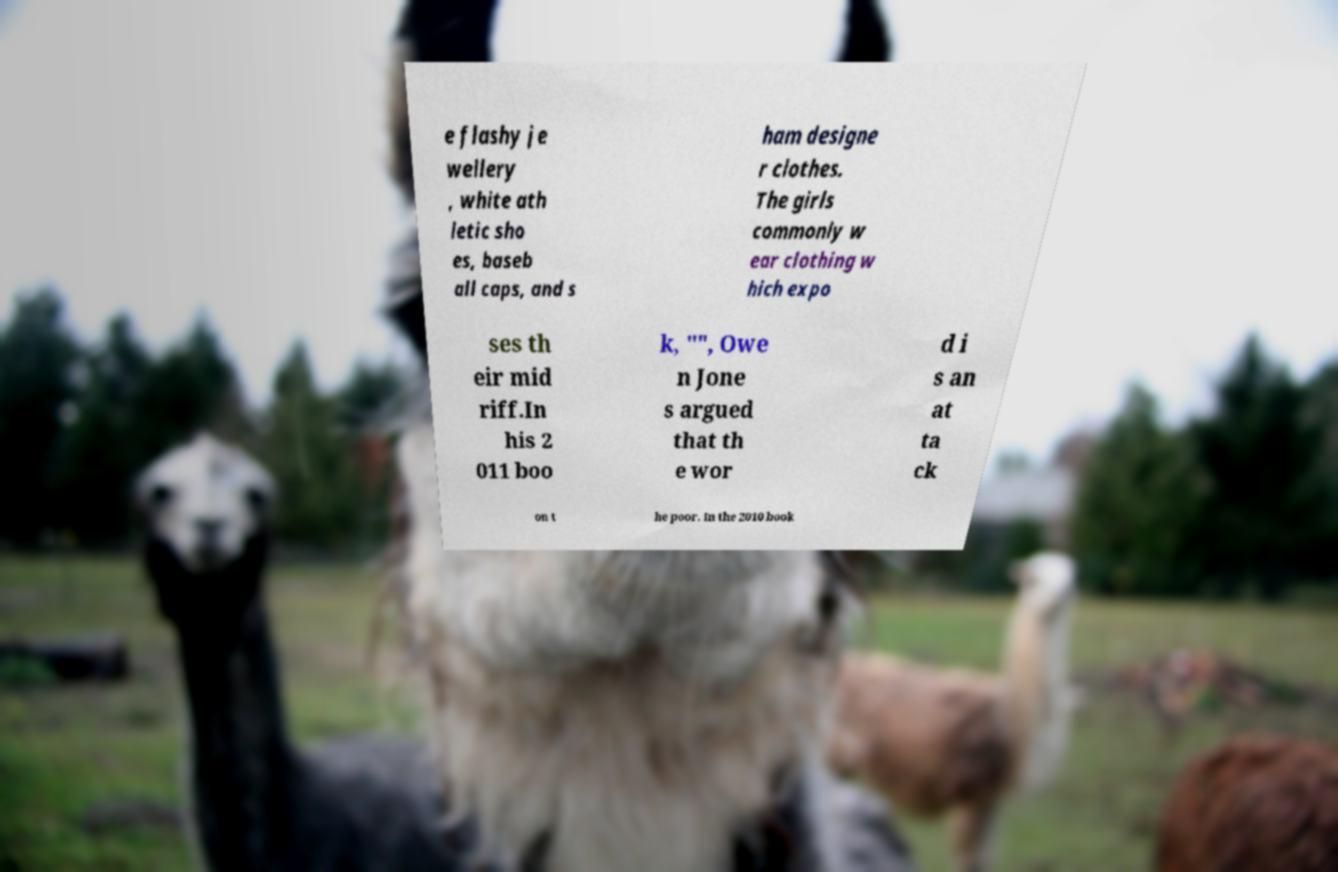I need the written content from this picture converted into text. Can you do that? e flashy je wellery , white ath letic sho es, baseb all caps, and s ham designe r clothes. The girls commonly w ear clothing w hich expo ses th eir mid riff.In his 2 011 boo k, "", Owe n Jone s argued that th e wor d i s an at ta ck on t he poor. In the 2010 book 